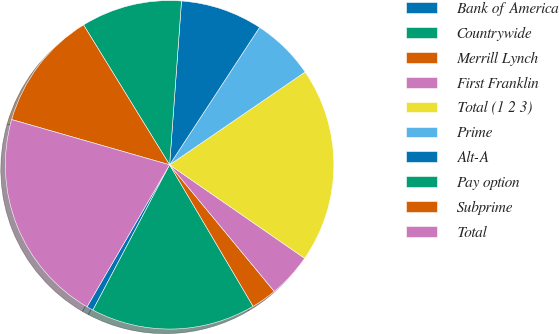Convert chart. <chart><loc_0><loc_0><loc_500><loc_500><pie_chart><fcel>Bank of America<fcel>Countrywide<fcel>Merrill Lynch<fcel>First Franklin<fcel>Total (1 2 3)<fcel>Prime<fcel>Alt-A<fcel>Pay option<fcel>Subprime<fcel>Total<nl><fcel>0.66%<fcel>16.21%<fcel>2.51%<fcel>4.37%<fcel>19.19%<fcel>6.22%<fcel>8.07%<fcel>9.93%<fcel>11.78%<fcel>21.05%<nl></chart> 